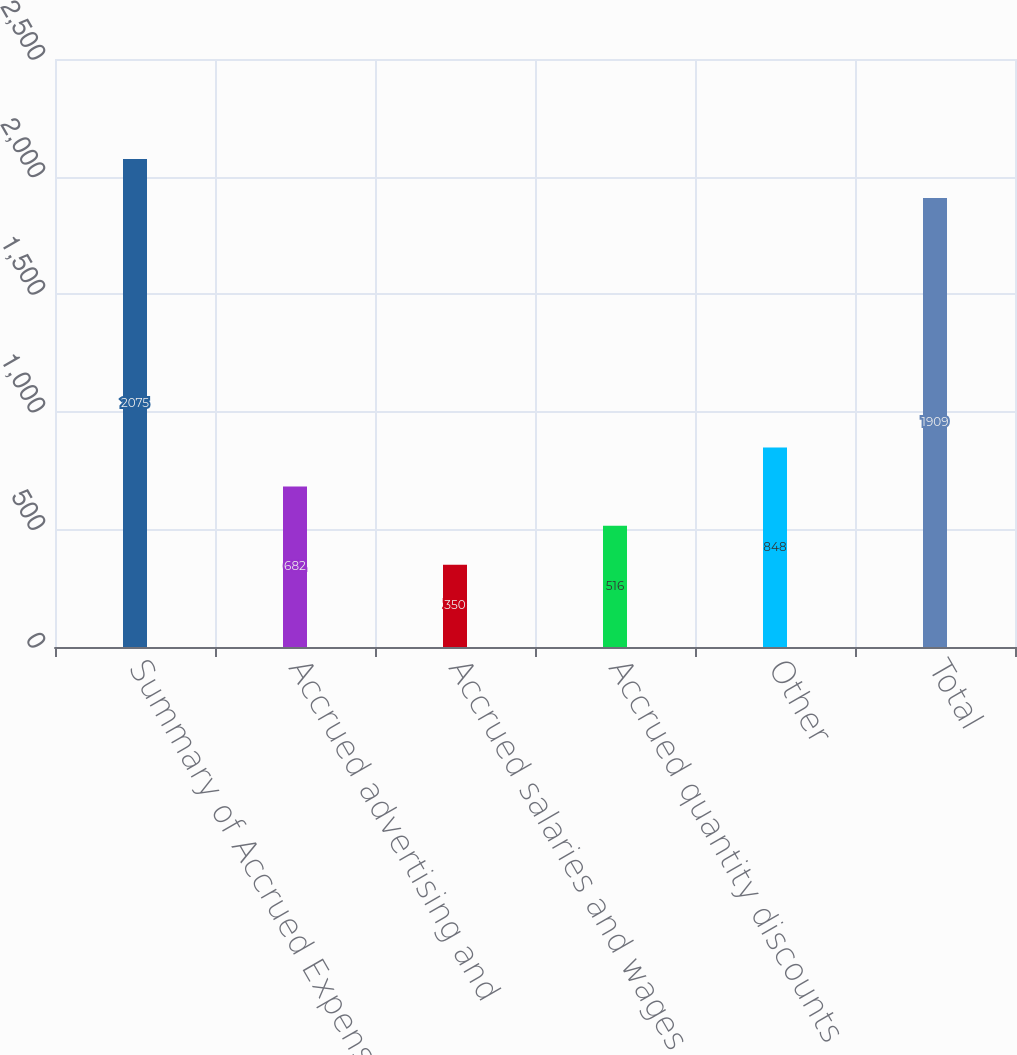<chart> <loc_0><loc_0><loc_500><loc_500><bar_chart><fcel>Summary of Accrued Expenses<fcel>Accrued advertising and<fcel>Accrued salaries and wages<fcel>Accrued quantity discounts<fcel>Other<fcel>Total<nl><fcel>2075<fcel>682<fcel>350<fcel>516<fcel>848<fcel>1909<nl></chart> 